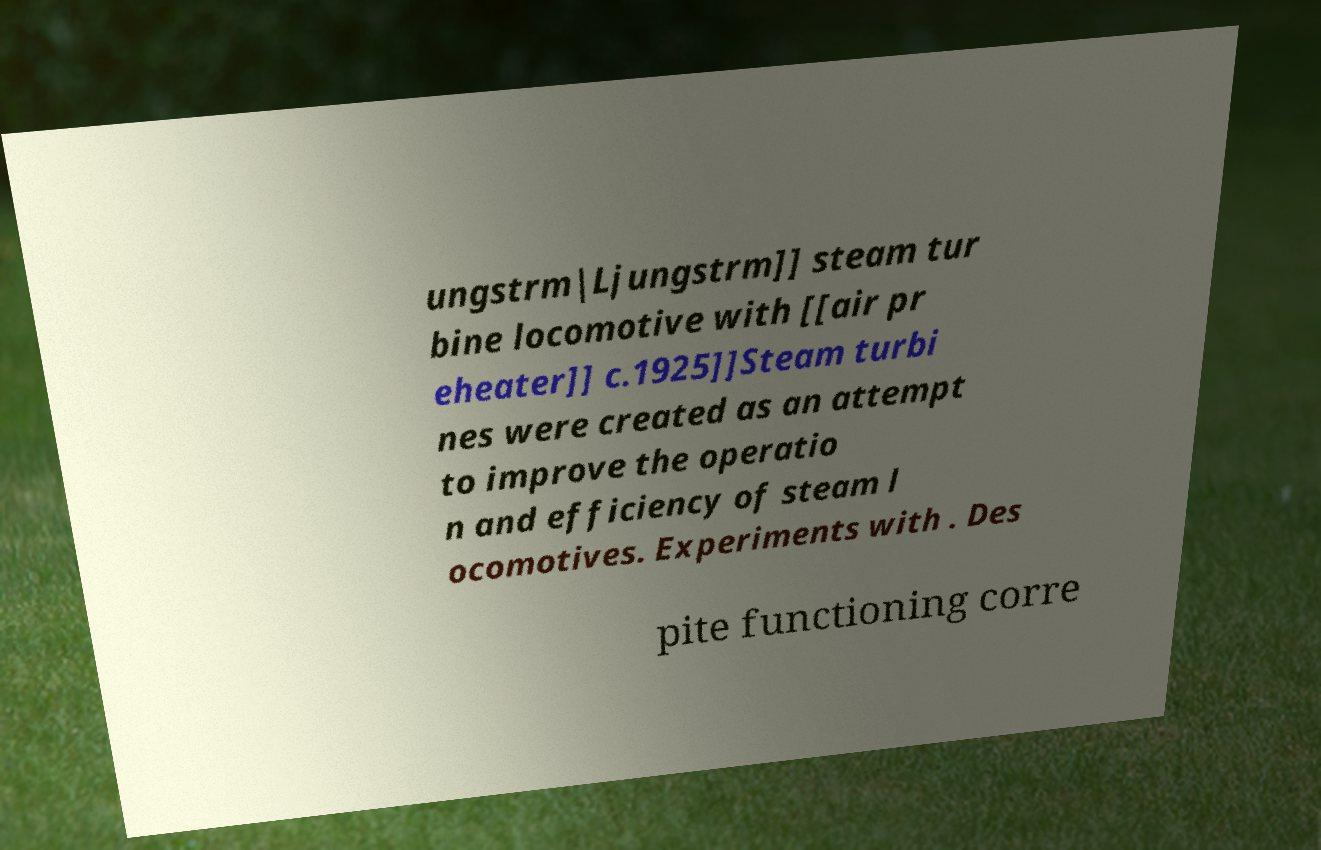Can you accurately transcribe the text from the provided image for me? ungstrm|Ljungstrm]] steam tur bine locomotive with [[air pr eheater]] c.1925]]Steam turbi nes were created as an attempt to improve the operatio n and efficiency of steam l ocomotives. Experiments with . Des pite functioning corre 